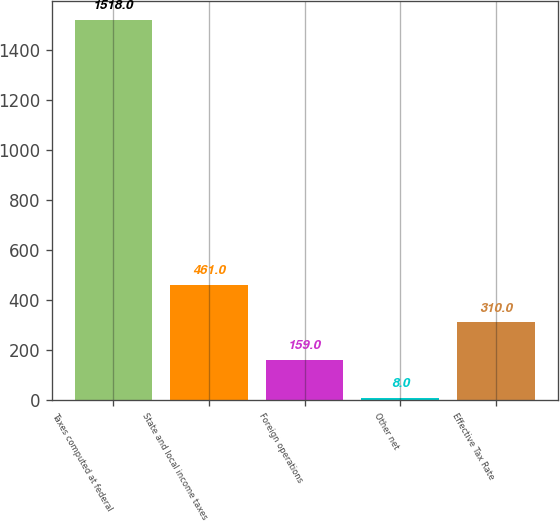Convert chart. <chart><loc_0><loc_0><loc_500><loc_500><bar_chart><fcel>Taxes computed at federal<fcel>State and local income taxes<fcel>Foreign operations<fcel>Other net<fcel>Effective Tax Rate<nl><fcel>1518<fcel>461<fcel>159<fcel>8<fcel>310<nl></chart> 